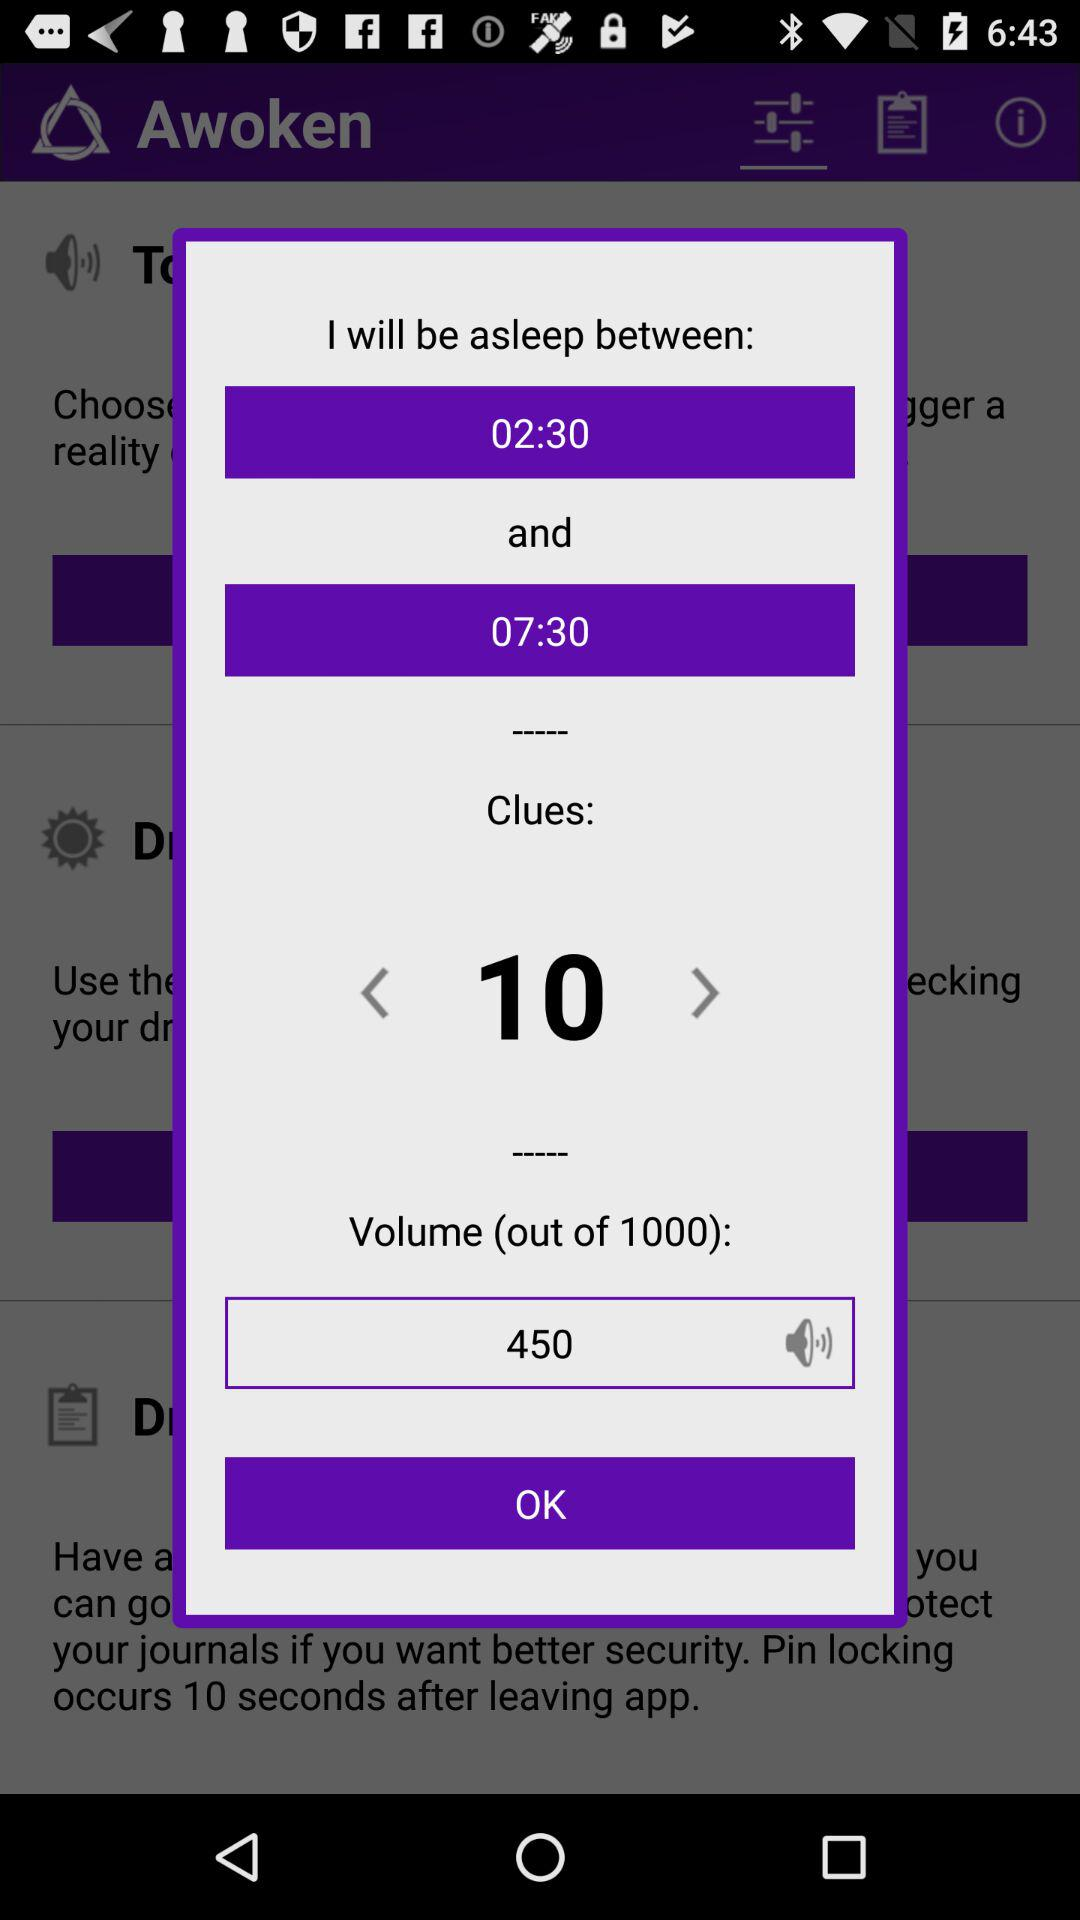What is the volume level?
Answer the question using a single word or phrase. 450 